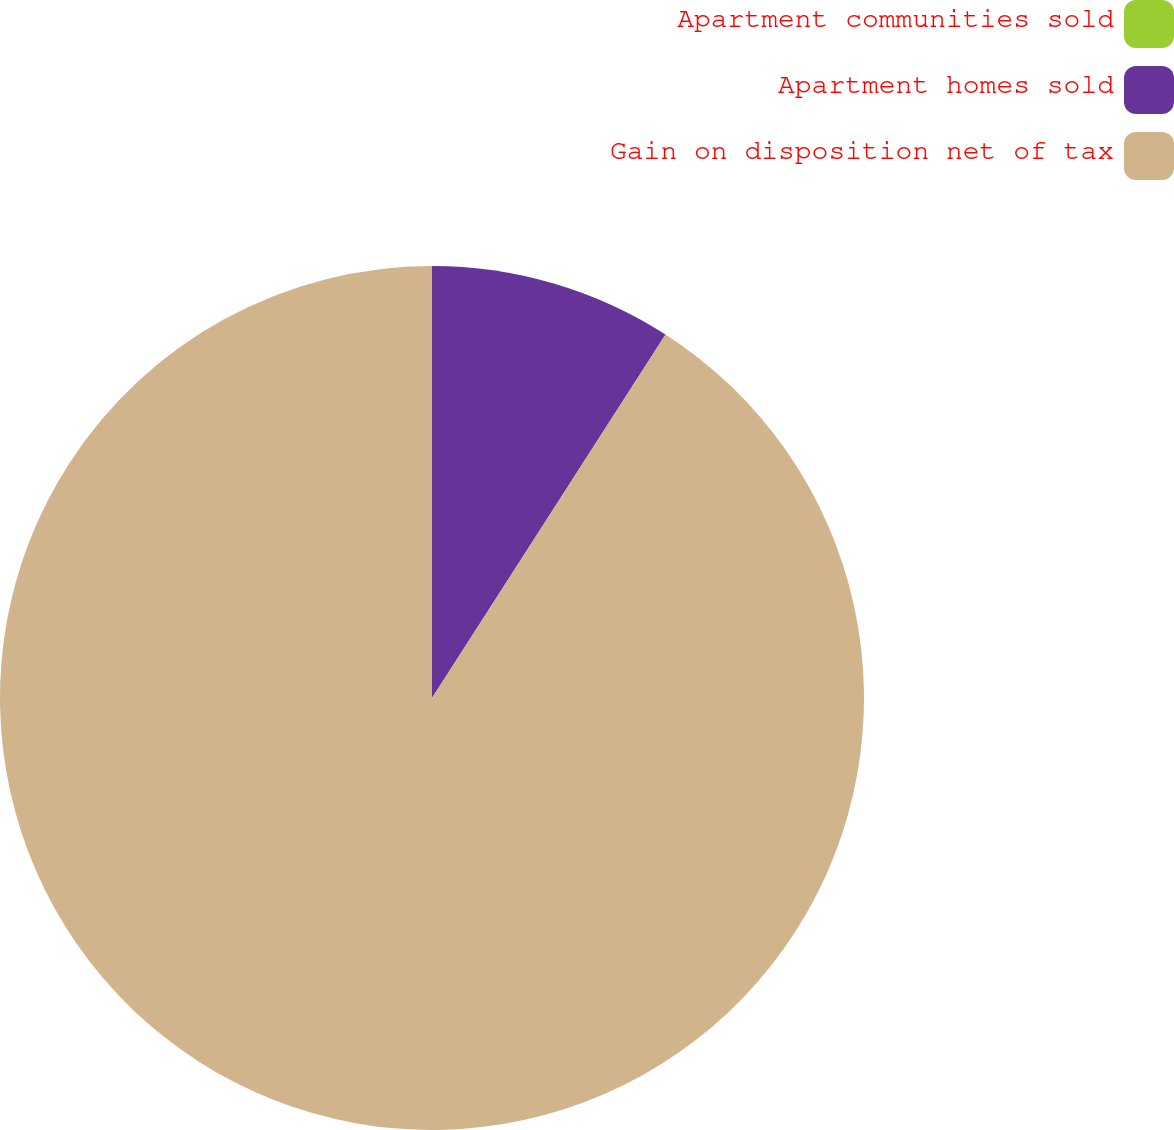<chart> <loc_0><loc_0><loc_500><loc_500><pie_chart><fcel>Apartment communities sold<fcel>Apartment homes sold<fcel>Gain on disposition net of tax<nl><fcel>0.0%<fcel>9.09%<fcel>90.91%<nl></chart> 